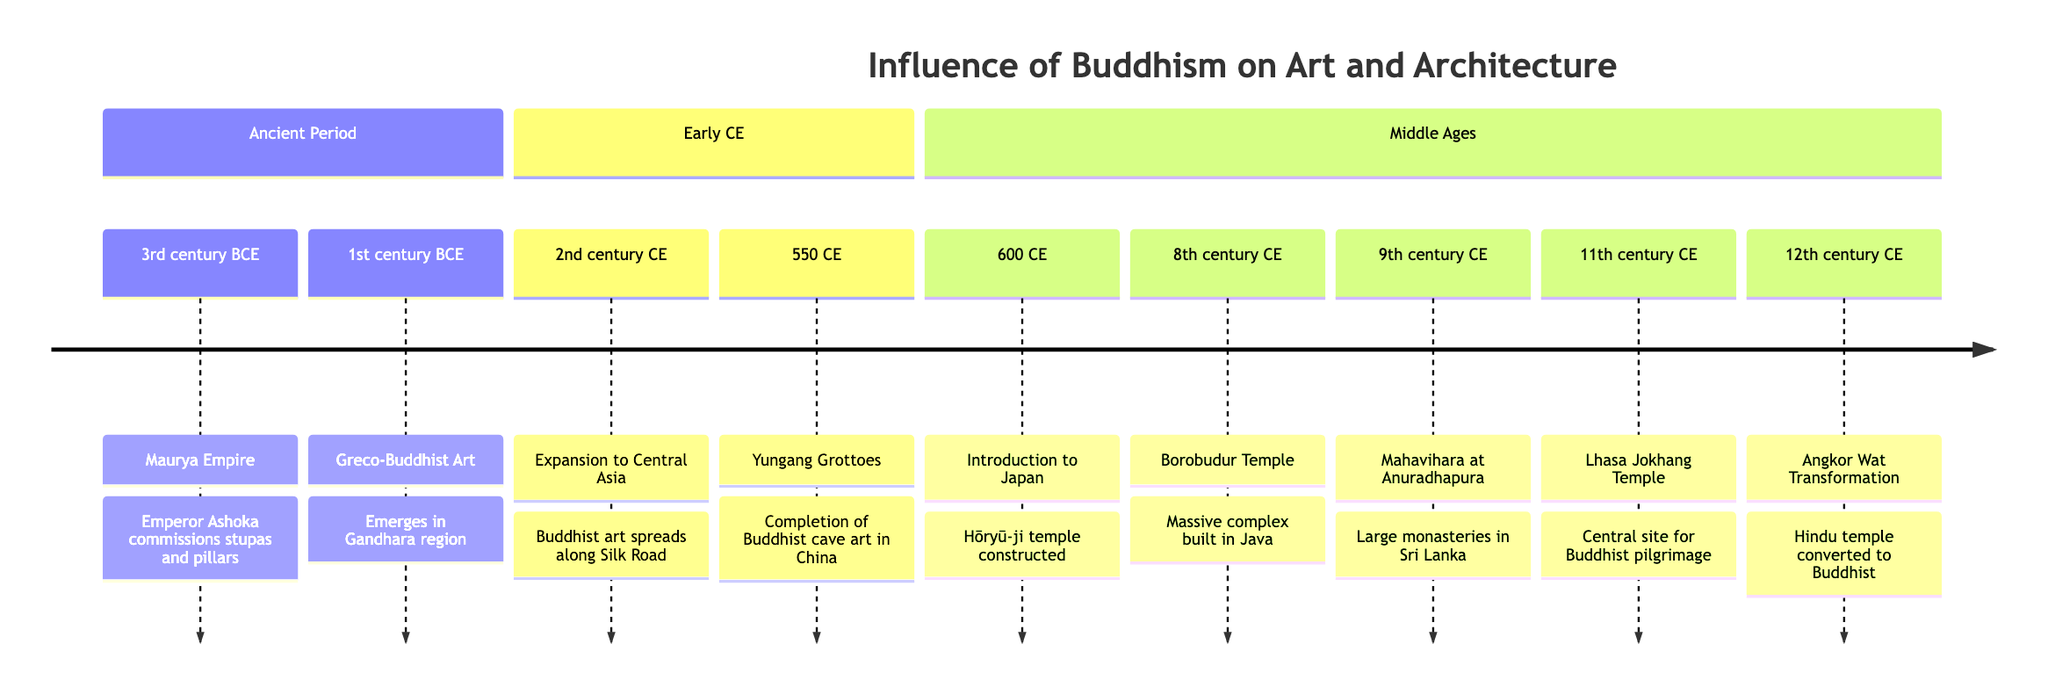What event took place circa 3rd century BCE? According to the timeline, the event that took place around the 3rd century BCE is the Maurya Empire, where Emperor Ashoka commissioned the construction of stupas and pillars with Buddhist inscriptions.
Answer: Maurya Empire Which region is associated with the emergence of Greco-Buddhist Art? The timeline indicates that Greco-Buddhist Art emerged in the Gandhara region, which corresponds to present-day Pakistan and Afghanistan.
Answer: Gandhara region What significant Buddhist structure was completed in 550 CE? Referring to the timeline, the Yungang Grottoes featuring Buddhist cave art and statues were completed in 550 CE.
Answer: Yungang Grottoes How many key events are listed in the Middle Ages section? By examining the events listed under the Middle Ages section of the timeline, there are six key events detailed, including the construction of various temples and the Jokhang Temple's establishment.
Answer: 6 What transformation did Angkor Wat undergo in the 12th century CE? The timeline states that in the 12th century CE, Angkor Wat was transformed from a Hindu temple into a Buddhist temple by the Khmer Empire.
Answer: Converted to a Buddhist temple Which event marks the introduction of Buddhism to Japan? The timeline specifies that the event marking Buddhism’s introduction to Japan occurred around 600 CE with the construction of the Hōryū-ji temple.
Answer: Hōryū-ji temple constructed In what century did Buddhism begin to spread along the Silk Road? According to the timeline, Buddhism began to spread along the Silk Road in the 2nd century CE.
Answer: 2nd century CE Which event occurred first: the completion of the Yungang Grottoes or the construction of Borobudur? To answer this, I compare the dates in the timeline. The Yungang Grottoes were completed in 550 CE, while the construction of Borobudur took place in the 8th century CE, which means the former occurred first.
Answer: Completion of the Yungang Grottoes What is a significant feature of the Jokhang Temple established in the 11th century CE? The timeline highlights that the Jokhang Temple became a central site for Buddhist pilgrimage, indicating its importance in the context of Buddhist architecture and community.
Answer: Central site for Buddhist pilgrimage 